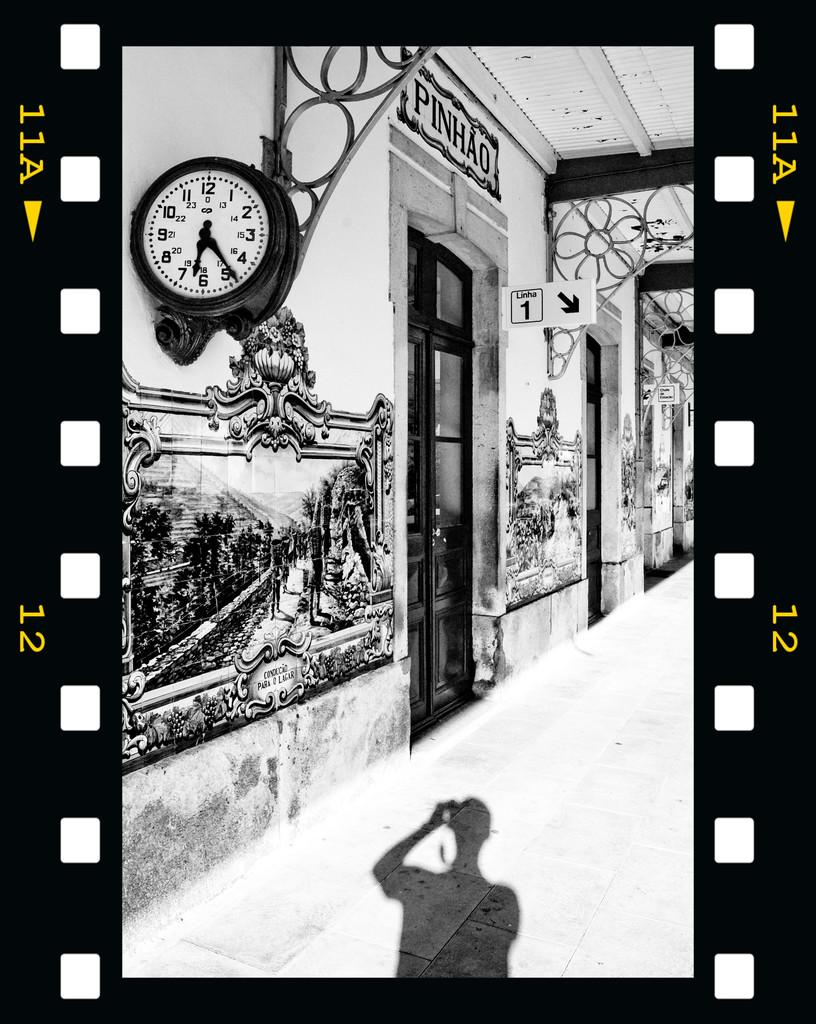Provide a one-sentence caption for the provided image. Outside of the Pinhao store with a large wall clock on the side. 